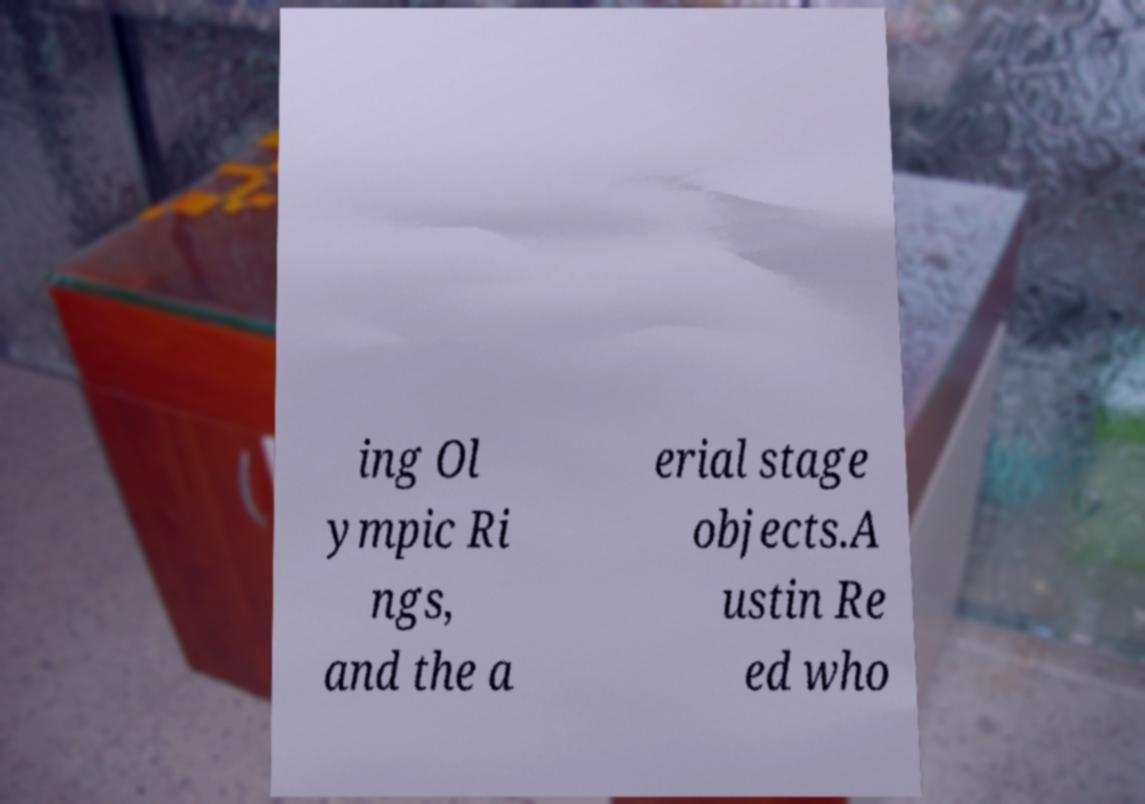For documentation purposes, I need the text within this image transcribed. Could you provide that? ing Ol ympic Ri ngs, and the a erial stage objects.A ustin Re ed who 